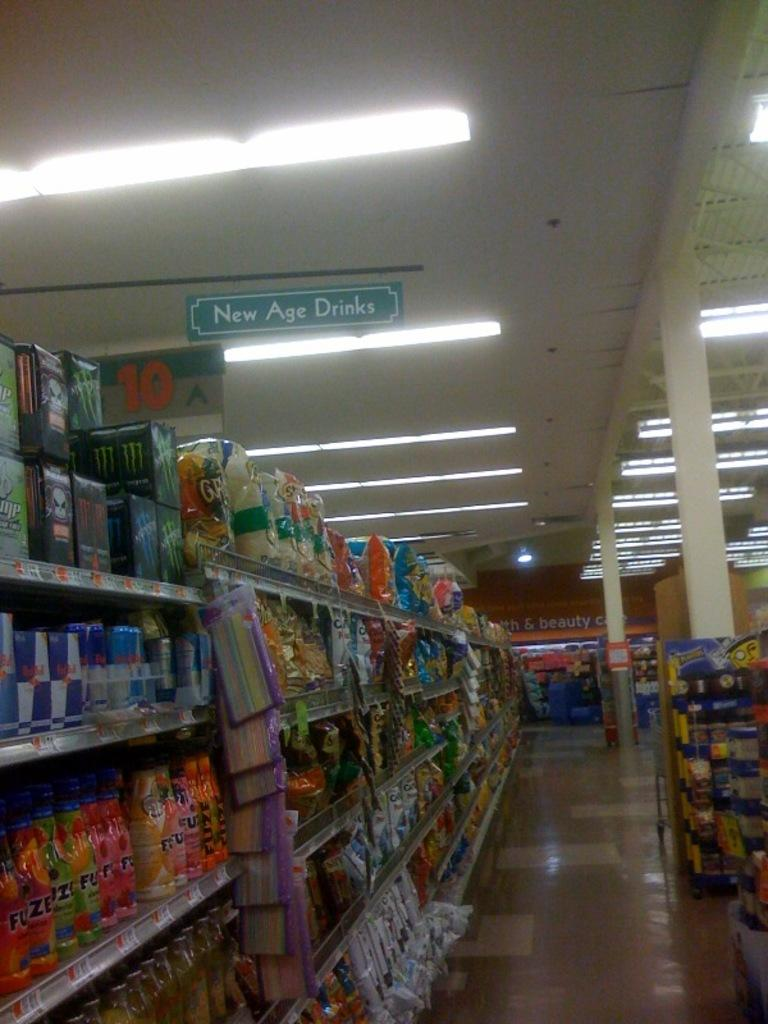<image>
Describe the image concisely. an aisle in the grocery store labeled new age drinks 